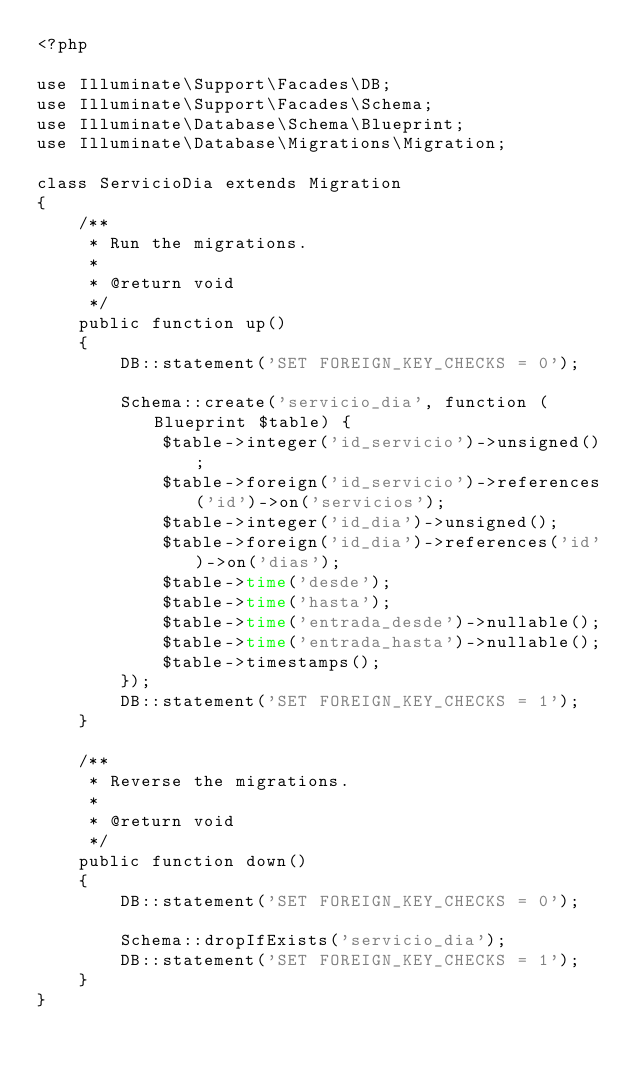<code> <loc_0><loc_0><loc_500><loc_500><_PHP_><?php

use Illuminate\Support\Facades\DB;
use Illuminate\Support\Facades\Schema;
use Illuminate\Database\Schema\Blueprint;
use Illuminate\Database\Migrations\Migration;

class ServicioDia extends Migration
{
    /**
     * Run the migrations.
     *
     * @return void
     */
    public function up()
    {
        DB::statement('SET FOREIGN_KEY_CHECKS = 0');

        Schema::create('servicio_dia', function (Blueprint $table) {
            $table->integer('id_servicio')->unsigned();
            $table->foreign('id_servicio')->references('id')->on('servicios');
            $table->integer('id_dia')->unsigned();
            $table->foreign('id_dia')->references('id')->on('dias');
            $table->time('desde');
            $table->time('hasta');
            $table->time('entrada_desde')->nullable();
            $table->time('entrada_hasta')->nullable();
            $table->timestamps();
        });
        DB::statement('SET FOREIGN_KEY_CHECKS = 1');
    }

    /**
     * Reverse the migrations.
     *
     * @return void
     */
    public function down()
    {
        DB::statement('SET FOREIGN_KEY_CHECKS = 0');

        Schema::dropIfExists('servicio_dia');
        DB::statement('SET FOREIGN_KEY_CHECKS = 1');
    }
}
</code> 